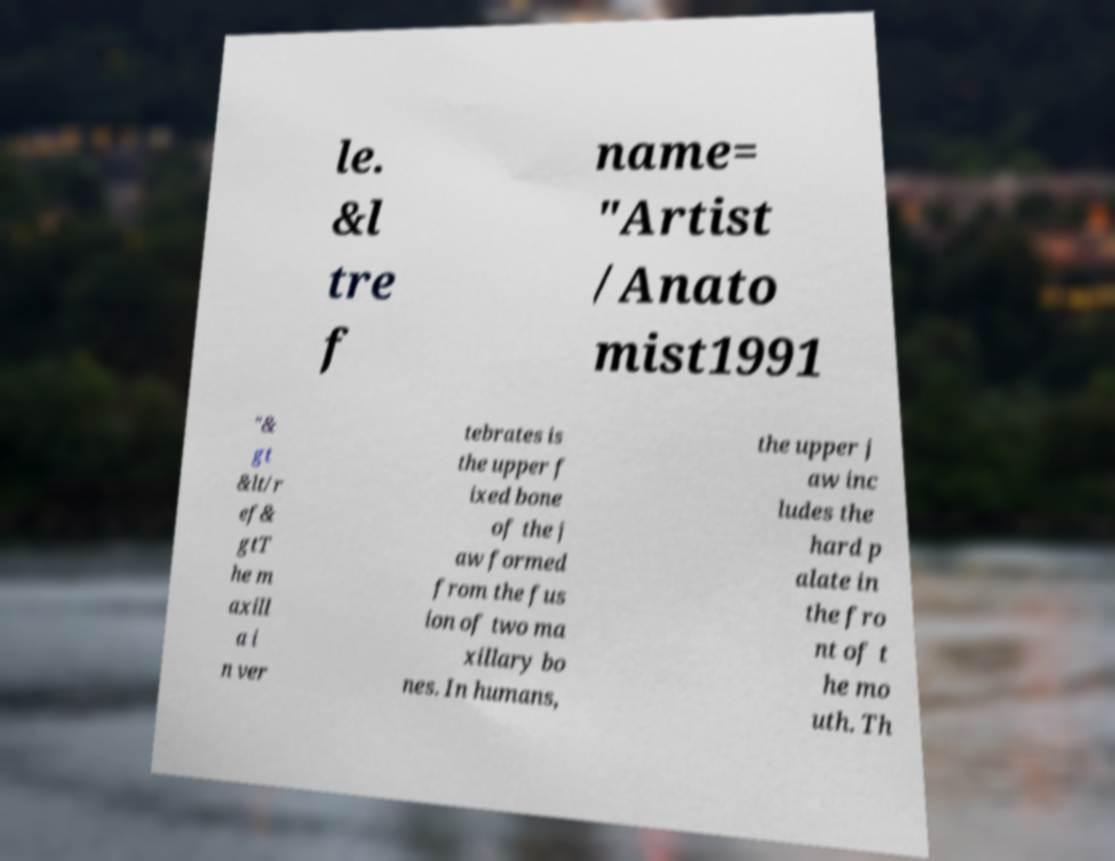Could you assist in decoding the text presented in this image and type it out clearly? le. &l tre f name= "Artist /Anato mist1991 "& gt &lt/r ef& gtT he m axill a i n ver tebrates is the upper f ixed bone of the j aw formed from the fus ion of two ma xillary bo nes. In humans, the upper j aw inc ludes the hard p alate in the fro nt of t he mo uth. Th 